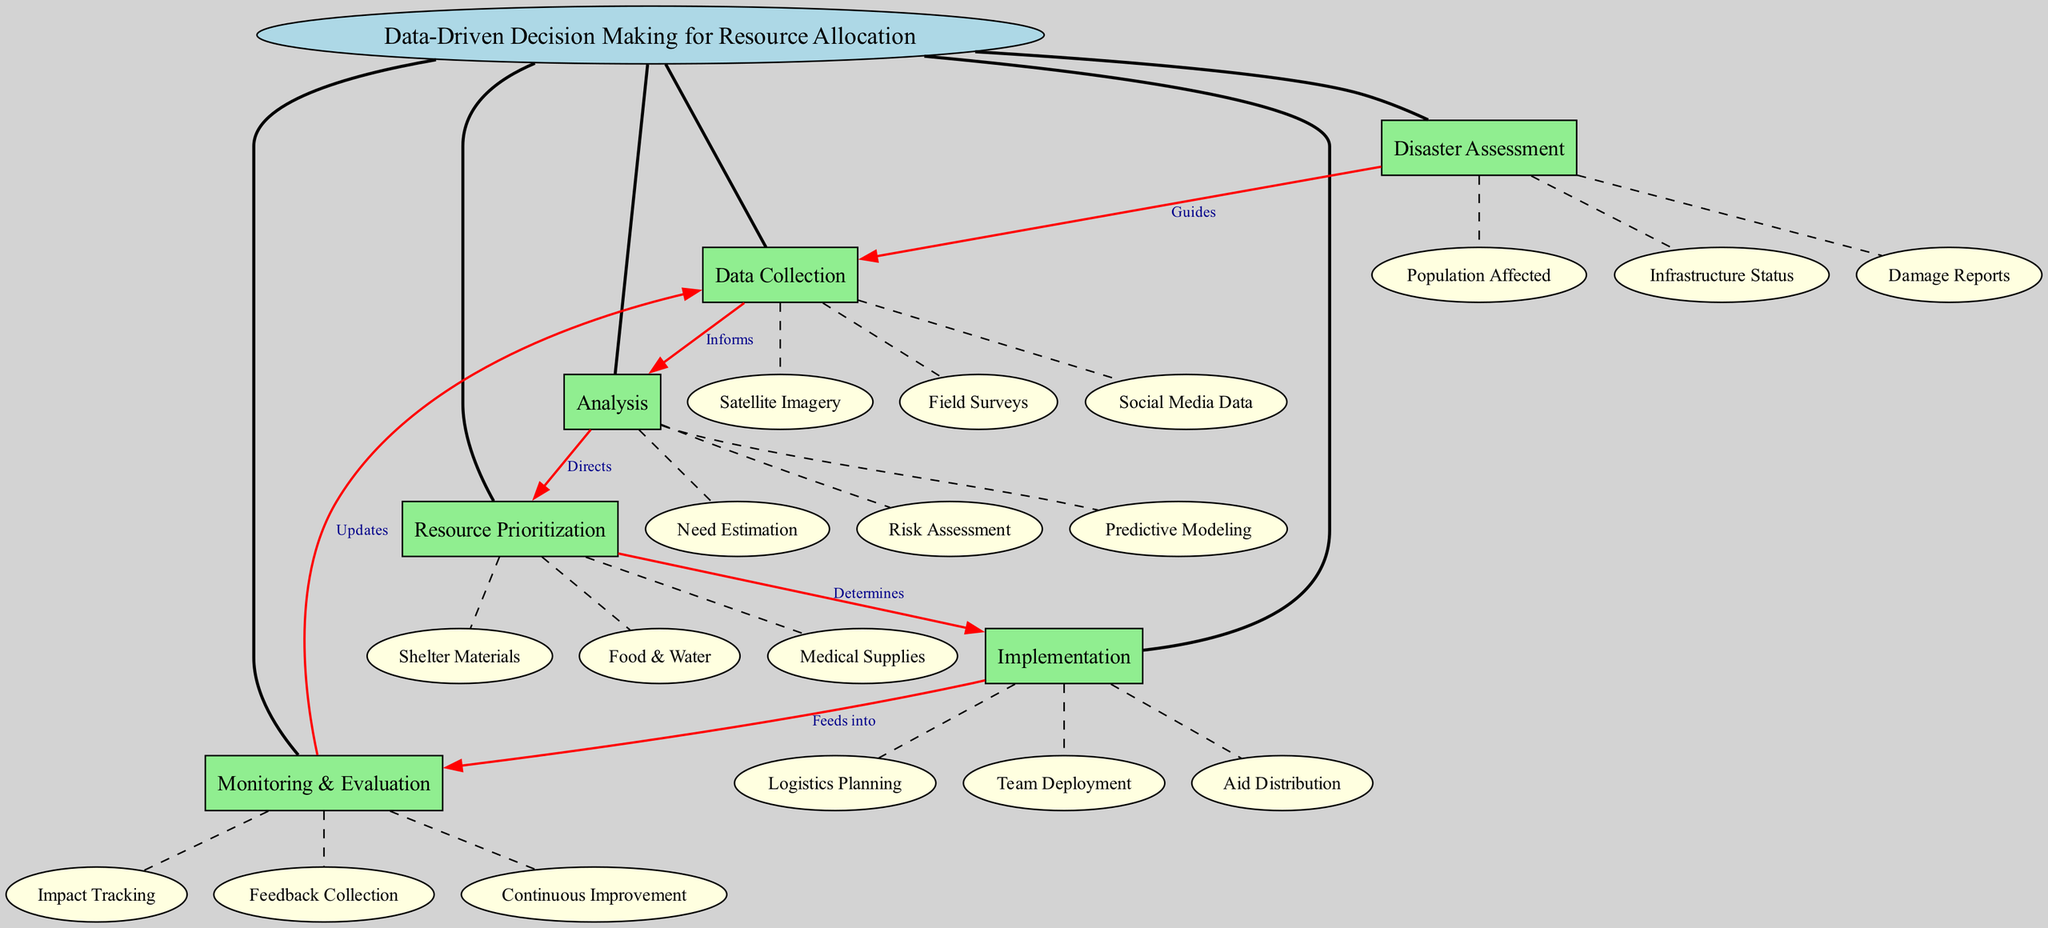What is the central concept of the diagram? The central concept is explicitly stated at the top of the diagram, which is "Data-Driven Decision Making for Resource Allocation."
Answer: Data-Driven Decision Making for Resource Allocation How many main nodes are present in the diagram? The diagram lists six main nodes branching from the central concept, which include Disaster Assessment, Data Collection, Analysis, Resource Prioritization, Implementation, and Monitoring & Evaluation.
Answer: Six What sub-node is associated with "Resource Prioritization"? The sub-nodes under "Resource Prioritization" include Food & Water, Medical Supplies, and Shelter Materials; any of these can answer the question.
Answer: Food & Water What is the relationship between "Data Collection" and "Analysis"? The diagram indicates that "Data Collection" informs "Analysis." This shows the flow of information from data gathering to the analytical process.
Answer: Informs Which node directly precedes "Implementation" in the diagram? A look at the connections reveals that "Resource Prioritization" is the direct precursor to "Implementation," as indicated by the labeled edge "Determines."
Answer: Resource Prioritization What does "Monitoring & Evaluation" feed into? The diagram shows that "Monitoring & Evaluation" feeds into "Data Collection," indicating a cyclical process where evaluation aids in future data collection efforts.
Answer: Data Collection How many edges connect "Disaster Assessment" to other nodes? "Disaster Assessment" connects to only one other node, which is "Data Collection," represented by a guiding relationship in the diagram.
Answer: One What type of data is mentioned under "Data Collection"? The sub-nodes listed under "Data Collection" include Satellite Imagery, Field Surveys, and Social Media Data, any of which can be mentioned as examples of data types collected.
Answer: Satellite Imagery What does "Implementation" consist of according to the diagram? The sub-nodes outline three components of "Implementation," which are Logistics Planning, Team Deployment, and Aid Distribution, any of which are valid answers.
Answer: Logistics Planning What kind of feedback does "Monitoring & Evaluation" utilize? The final node under "Monitoring & Evaluation" indicates that feedback collection is part of the evaluation process, helping to improve subsequent efforts.
Answer: Feedback Collection 